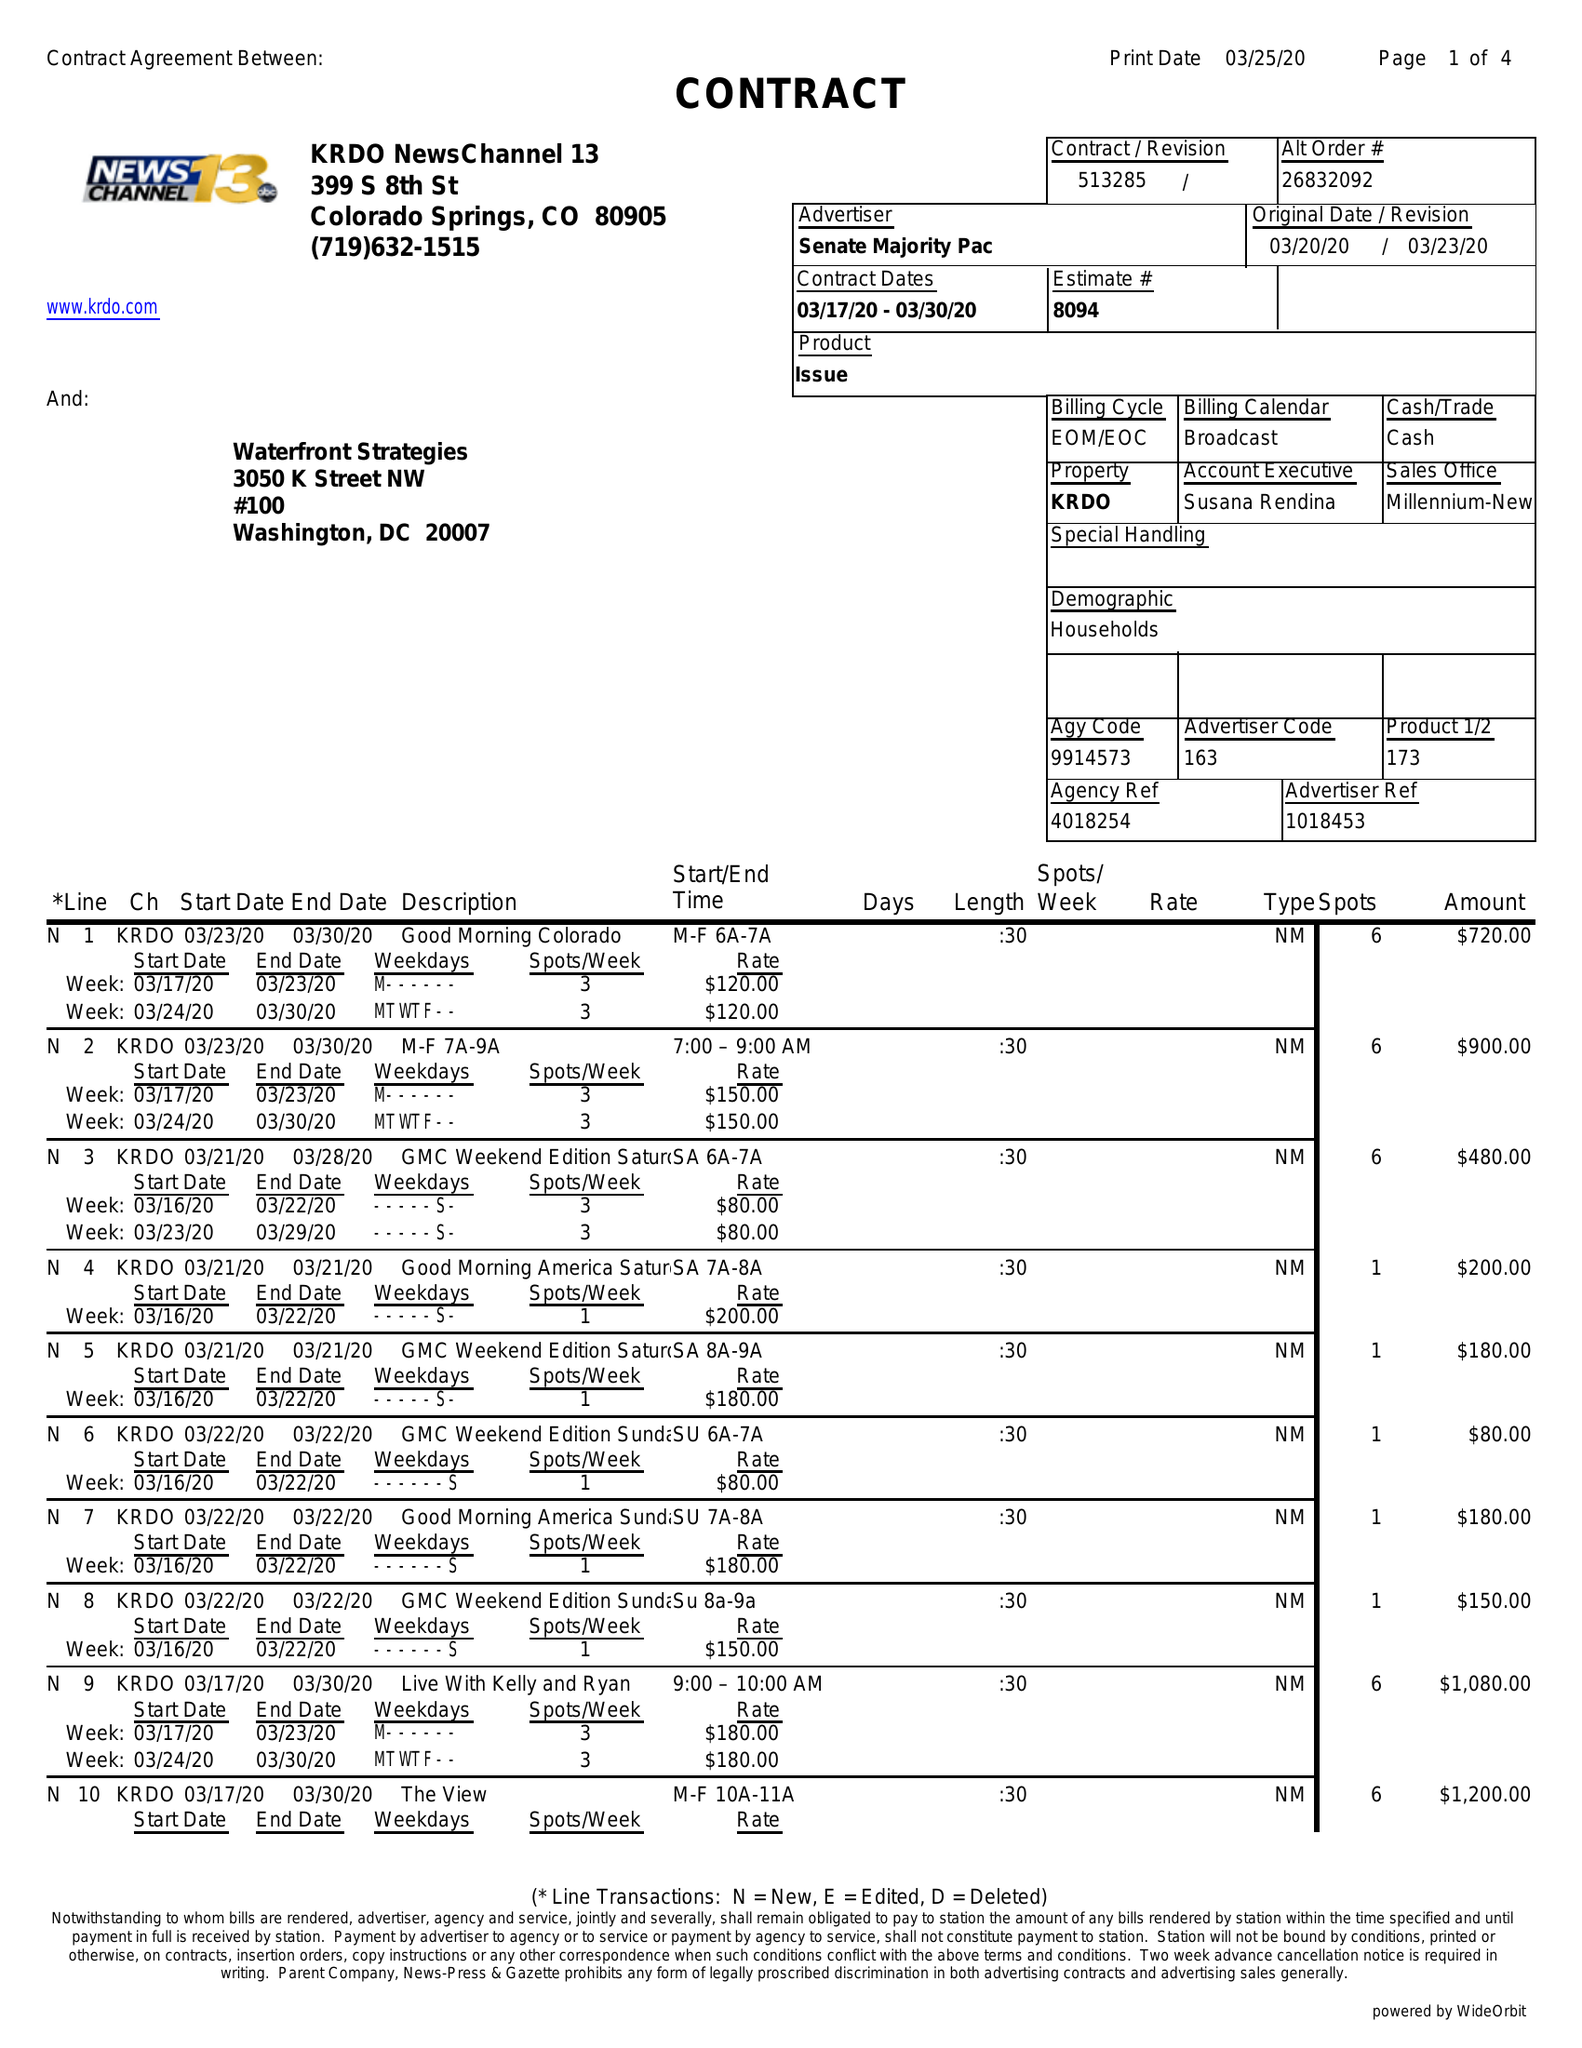What is the value for the flight_from?
Answer the question using a single word or phrase. 03/17/20 